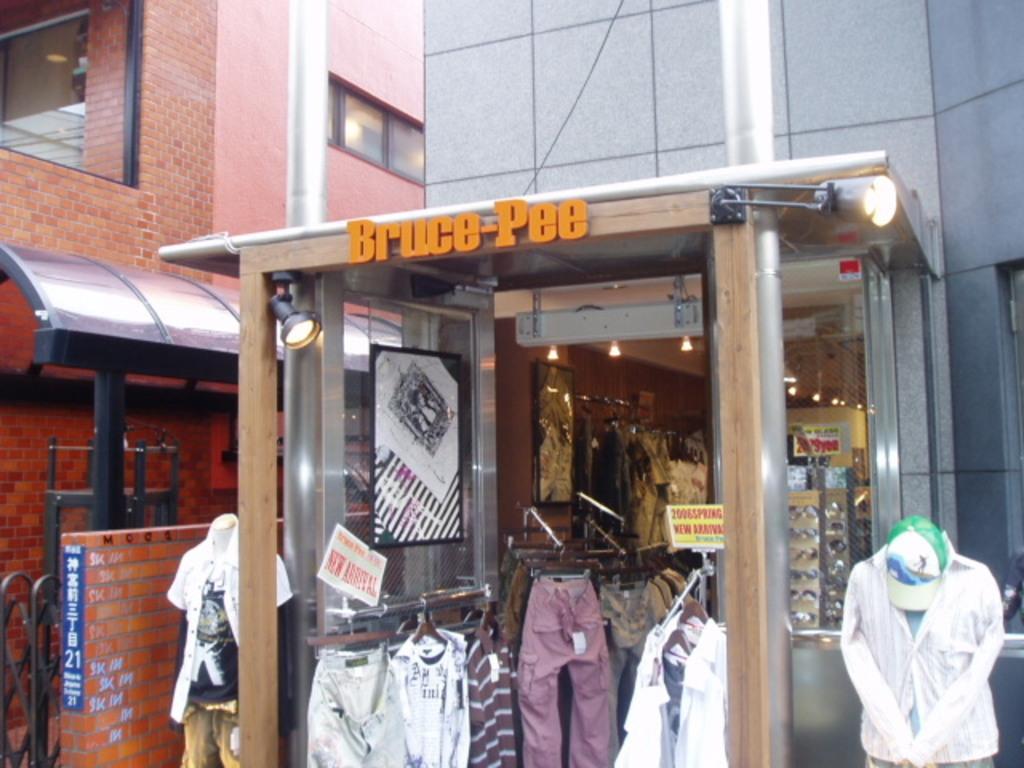Please provide a concise description of this image. In this image in the foreground there are buildings visible, there is a shop, on the building there is a name plate attached to the entrance gate of the building, there are some clots visible on the hanger in the shop, there are some spectacle, lights attached to the roof in the shop. 